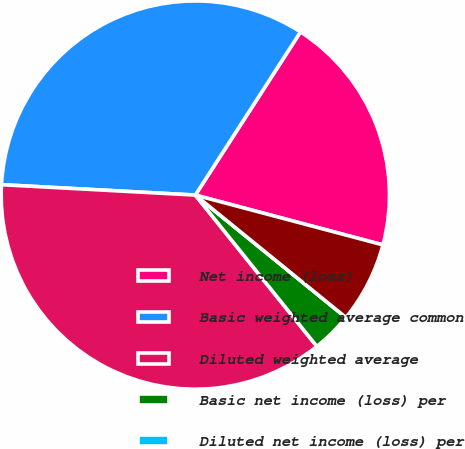Convert chart. <chart><loc_0><loc_0><loc_500><loc_500><pie_chart><fcel>Net income (loss)<fcel>Basic weighted average common<fcel>Diluted weighted average<fcel>Basic net income (loss) per<fcel>Diluted net income (loss) per<fcel>Outstanding stock options<nl><fcel>20.02%<fcel>33.26%<fcel>36.62%<fcel>3.37%<fcel>0.0%<fcel>6.73%<nl></chart> 